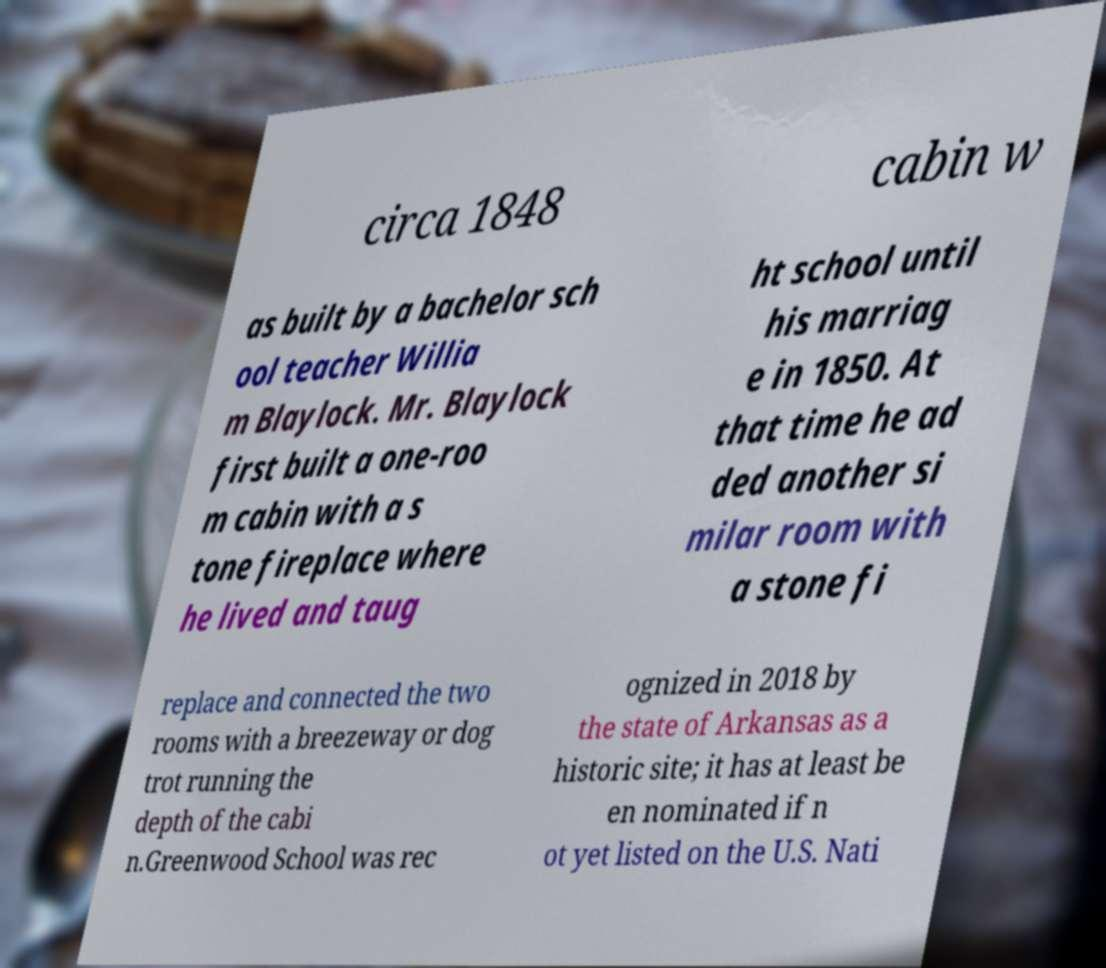There's text embedded in this image that I need extracted. Can you transcribe it verbatim? circa 1848 cabin w as built by a bachelor sch ool teacher Willia m Blaylock. Mr. Blaylock first built a one-roo m cabin with a s tone fireplace where he lived and taug ht school until his marriag e in 1850. At that time he ad ded another si milar room with a stone fi replace and connected the two rooms with a breezeway or dog trot running the depth of the cabi n.Greenwood School was rec ognized in 2018 by the state of Arkansas as a historic site; it has at least be en nominated if n ot yet listed on the U.S. Nati 